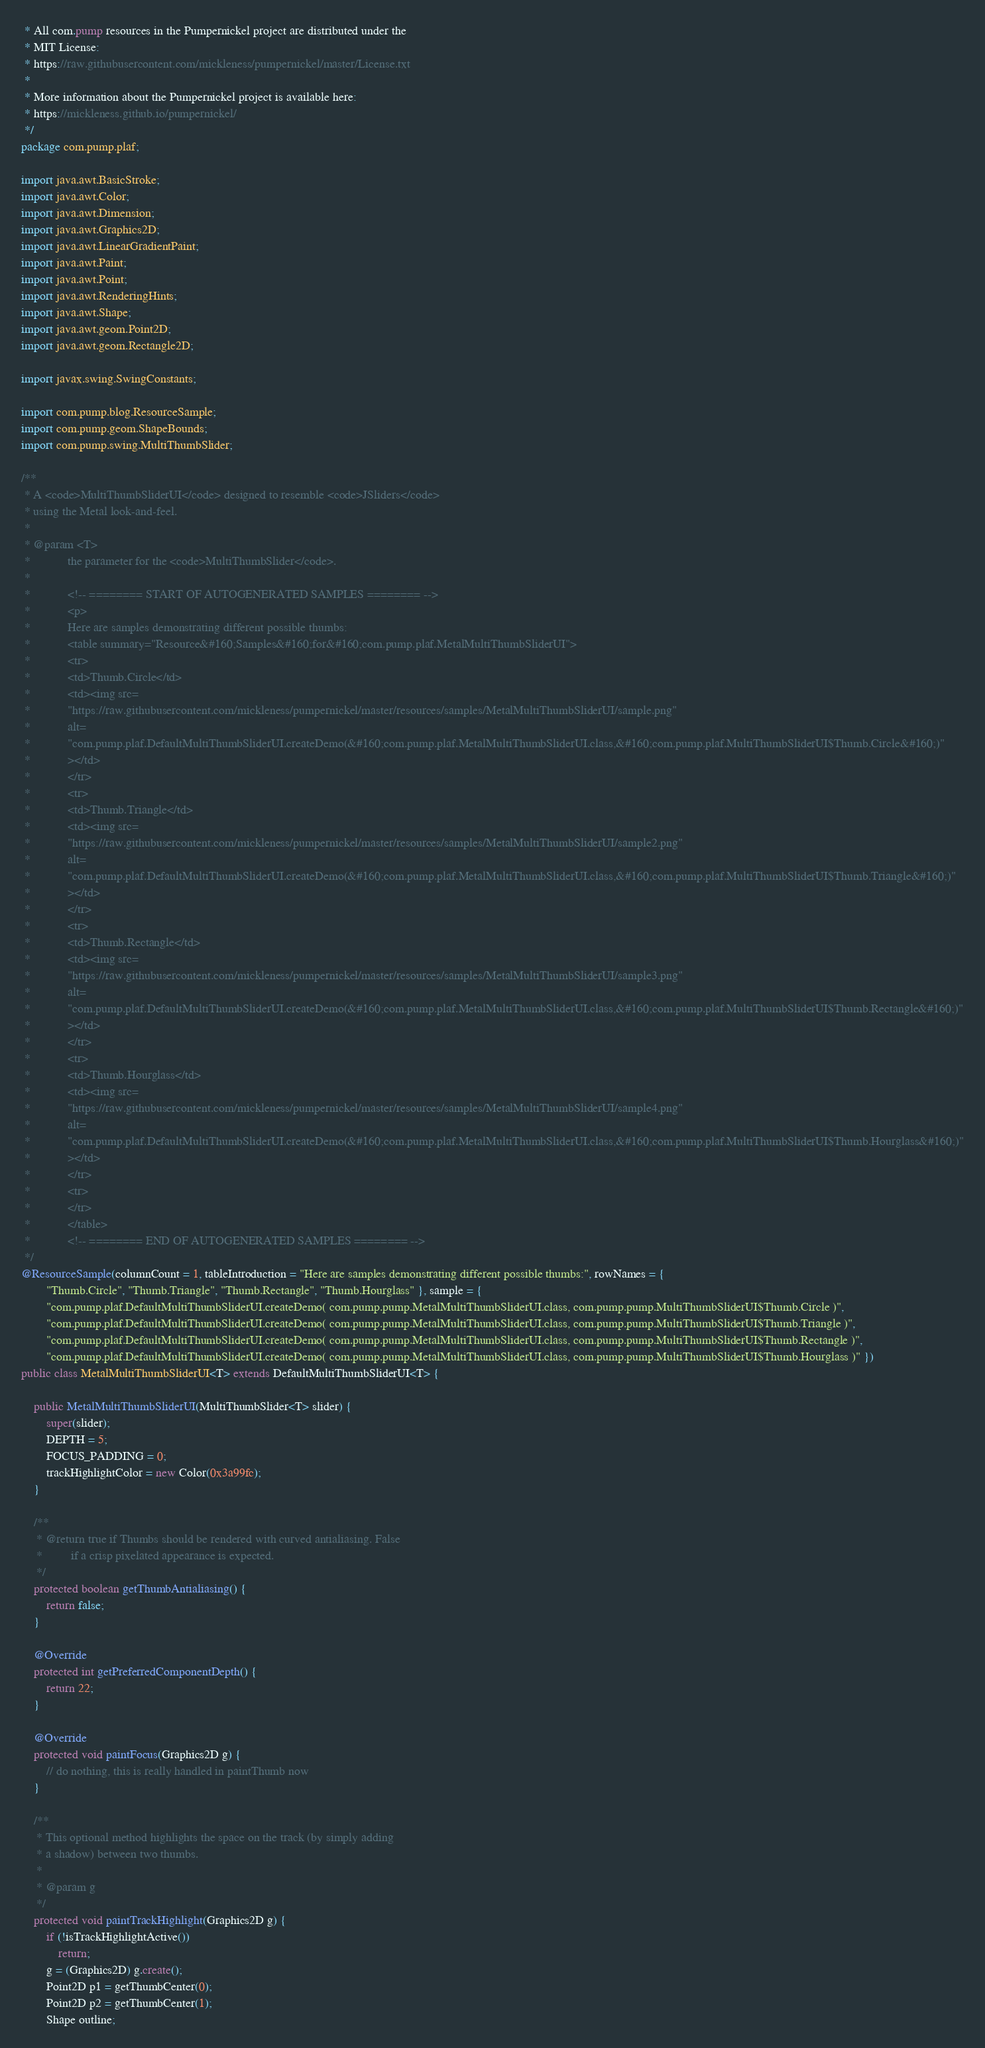Convert code to text. <code><loc_0><loc_0><loc_500><loc_500><_Java_> * All com.pump resources in the Pumpernickel project are distributed under the
 * MIT License:
 * https://raw.githubusercontent.com/mickleness/pumpernickel/master/License.txt
 * 
 * More information about the Pumpernickel project is available here:
 * https://mickleness.github.io/pumpernickel/
 */
package com.pump.plaf;

import java.awt.BasicStroke;
import java.awt.Color;
import java.awt.Dimension;
import java.awt.Graphics2D;
import java.awt.LinearGradientPaint;
import java.awt.Paint;
import java.awt.Point;
import java.awt.RenderingHints;
import java.awt.Shape;
import java.awt.geom.Point2D;
import java.awt.geom.Rectangle2D;

import javax.swing.SwingConstants;

import com.pump.blog.ResourceSample;
import com.pump.geom.ShapeBounds;
import com.pump.swing.MultiThumbSlider;

/**
 * A <code>MultiThumbSliderUI</code> designed to resemble <code>JSliders</code>
 * using the Metal look-and-feel.
 *
 * @param <T>
 *            the parameter for the <code>MultiThumbSlider</code>.
 * 
 *            <!-- ======== START OF AUTOGENERATED SAMPLES ======== -->
 *            <p>
 *            Here are samples demonstrating different possible thumbs:
 *            <table summary="Resource&#160;Samples&#160;for&#160;com.pump.plaf.MetalMultiThumbSliderUI">
 *            <tr>
 *            <td>Thumb.Circle</td>
 *            <td><img src=
 *            "https://raw.githubusercontent.com/mickleness/pumpernickel/master/resources/samples/MetalMultiThumbSliderUI/sample.png"
 *            alt=
 *            "com.pump.plaf.DefaultMultiThumbSliderUI.createDemo(&#160;com.pump.plaf.MetalMultiThumbSliderUI.class,&#160;com.pump.plaf.MultiThumbSliderUI$Thumb.Circle&#160;)"
 *            ></td>
 *            </tr>
 *            <tr>
 *            <td>Thumb.Triangle</td>
 *            <td><img src=
 *            "https://raw.githubusercontent.com/mickleness/pumpernickel/master/resources/samples/MetalMultiThumbSliderUI/sample2.png"
 *            alt=
 *            "com.pump.plaf.DefaultMultiThumbSliderUI.createDemo(&#160;com.pump.plaf.MetalMultiThumbSliderUI.class,&#160;com.pump.plaf.MultiThumbSliderUI$Thumb.Triangle&#160;)"
 *            ></td>
 *            </tr>
 *            <tr>
 *            <td>Thumb.Rectangle</td>
 *            <td><img src=
 *            "https://raw.githubusercontent.com/mickleness/pumpernickel/master/resources/samples/MetalMultiThumbSliderUI/sample3.png"
 *            alt=
 *            "com.pump.plaf.DefaultMultiThumbSliderUI.createDemo(&#160;com.pump.plaf.MetalMultiThumbSliderUI.class,&#160;com.pump.plaf.MultiThumbSliderUI$Thumb.Rectangle&#160;)"
 *            ></td>
 *            </tr>
 *            <tr>
 *            <td>Thumb.Hourglass</td>
 *            <td><img src=
 *            "https://raw.githubusercontent.com/mickleness/pumpernickel/master/resources/samples/MetalMultiThumbSliderUI/sample4.png"
 *            alt=
 *            "com.pump.plaf.DefaultMultiThumbSliderUI.createDemo(&#160;com.pump.plaf.MetalMultiThumbSliderUI.class,&#160;com.pump.plaf.MultiThumbSliderUI$Thumb.Hourglass&#160;)"
 *            ></td>
 *            </tr>
 *            <tr>
 *            </tr>
 *            </table>
 *            <!-- ======== END OF AUTOGENERATED SAMPLES ======== -->
 */
@ResourceSample(columnCount = 1, tableIntroduction = "Here are samples demonstrating different possible thumbs:", rowNames = {
		"Thumb.Circle", "Thumb.Triangle", "Thumb.Rectangle", "Thumb.Hourglass" }, sample = {
		"com.pump.plaf.DefaultMultiThumbSliderUI.createDemo( com.pump.pump.MetalMultiThumbSliderUI.class, com.pump.pump.MultiThumbSliderUI$Thumb.Circle )",
		"com.pump.plaf.DefaultMultiThumbSliderUI.createDemo( com.pump.pump.MetalMultiThumbSliderUI.class, com.pump.pump.MultiThumbSliderUI$Thumb.Triangle )",
		"com.pump.plaf.DefaultMultiThumbSliderUI.createDemo( com.pump.pump.MetalMultiThumbSliderUI.class, com.pump.pump.MultiThumbSliderUI$Thumb.Rectangle )",
		"com.pump.plaf.DefaultMultiThumbSliderUI.createDemo( com.pump.pump.MetalMultiThumbSliderUI.class, com.pump.pump.MultiThumbSliderUI$Thumb.Hourglass )" })
public class MetalMultiThumbSliderUI<T> extends DefaultMultiThumbSliderUI<T> {

	public MetalMultiThumbSliderUI(MultiThumbSlider<T> slider) {
		super(slider);
		DEPTH = 5;
		FOCUS_PADDING = 0;
		trackHighlightColor = new Color(0x3a99fc);
	}

	/**
	 * @return true if Thumbs should be rendered with curved antialiasing. False
	 *         if a crisp pixelated appearance is expected.
	 */
	protected boolean getThumbAntialiasing() {
		return false;
	}

	@Override
	protected int getPreferredComponentDepth() {
		return 22;
	}

	@Override
	protected void paintFocus(Graphics2D g) {
		// do nothing, this is really handled in paintThumb now
	}

	/**
	 * This optional method highlights the space on the track (by simply adding
	 * a shadow) between two thumbs.
	 * 
	 * @param g
	 */
	protected void paintTrackHighlight(Graphics2D g) {
		if (!isTrackHighlightActive())
			return;
		g = (Graphics2D) g.create();
		Point2D p1 = getThumbCenter(0);
		Point2D p2 = getThumbCenter(1);
		Shape outline;</code> 